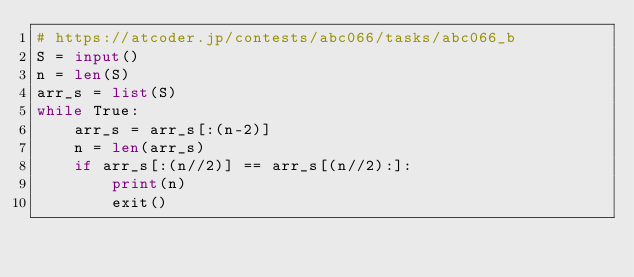Convert code to text. <code><loc_0><loc_0><loc_500><loc_500><_Python_># https://atcoder.jp/contests/abc066/tasks/abc066_b
S = input()
n = len(S)
arr_s = list(S)
while True:
    arr_s = arr_s[:(n-2)]
    n = len(arr_s)
    if arr_s[:(n//2)] == arr_s[(n//2):]:
        print(n)
        exit()
</code> 